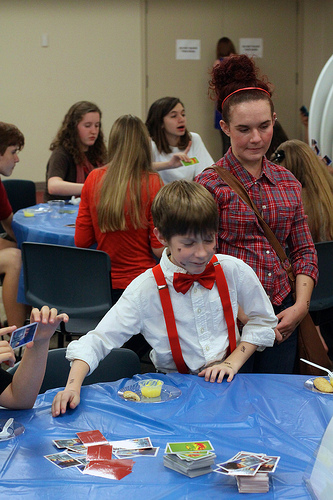<image>
Is there a boy behind the woman? No. The boy is not behind the woman. From this viewpoint, the boy appears to be positioned elsewhere in the scene. 